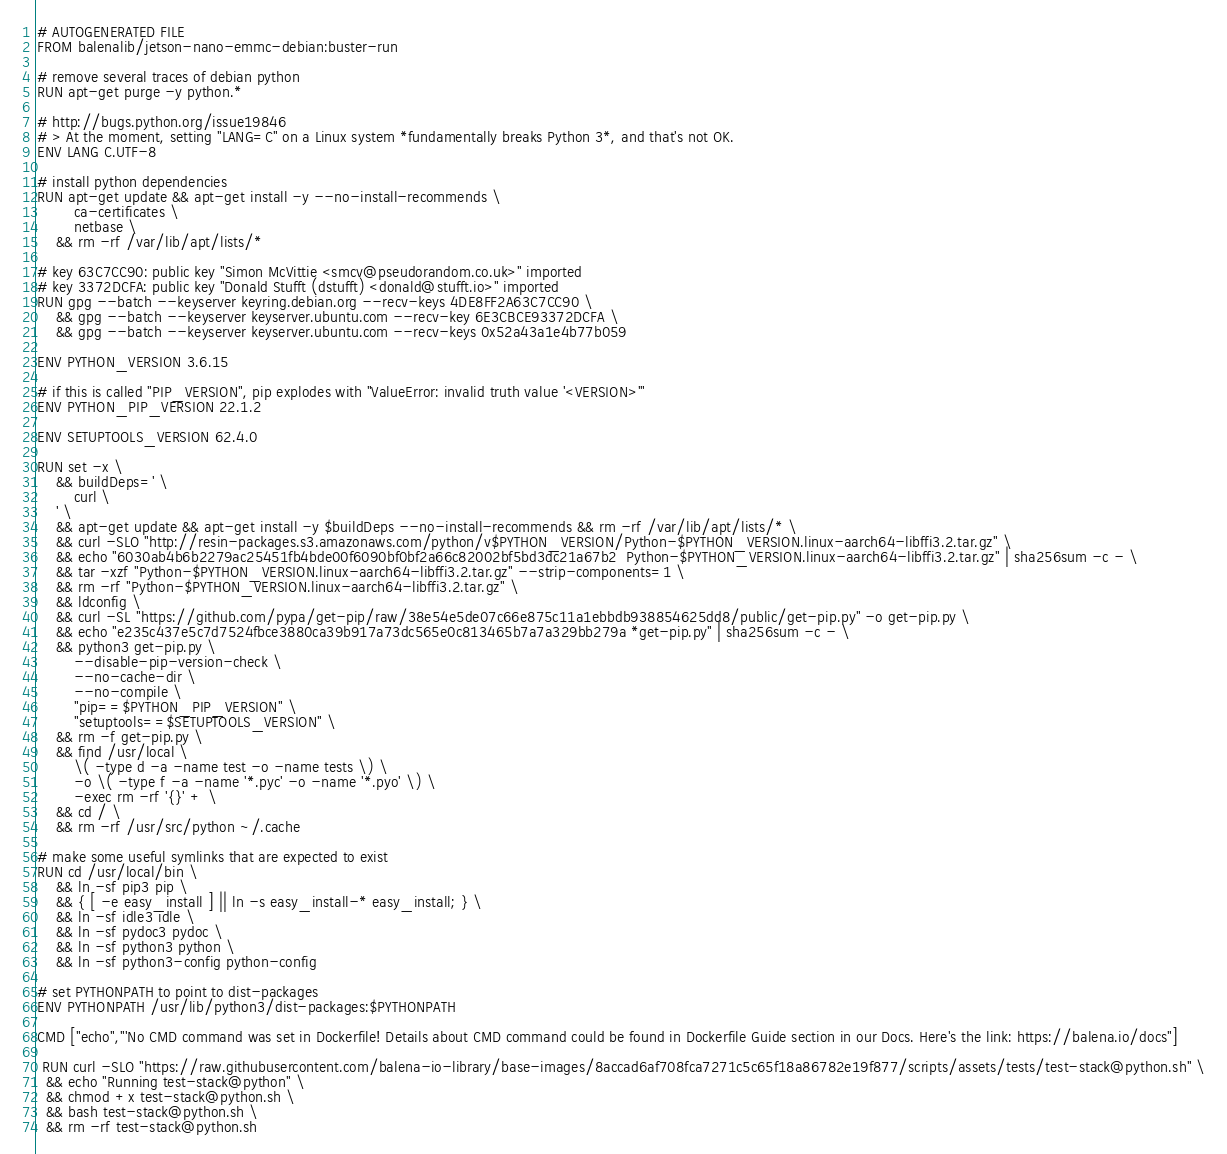<code> <loc_0><loc_0><loc_500><loc_500><_Dockerfile_># AUTOGENERATED FILE
FROM balenalib/jetson-nano-emmc-debian:buster-run

# remove several traces of debian python
RUN apt-get purge -y python.*

# http://bugs.python.org/issue19846
# > At the moment, setting "LANG=C" on a Linux system *fundamentally breaks Python 3*, and that's not OK.
ENV LANG C.UTF-8

# install python dependencies
RUN apt-get update && apt-get install -y --no-install-recommends \
		ca-certificates \
		netbase \
	&& rm -rf /var/lib/apt/lists/*

# key 63C7CC90: public key "Simon McVittie <smcv@pseudorandom.co.uk>" imported
# key 3372DCFA: public key "Donald Stufft (dstufft) <donald@stufft.io>" imported
RUN gpg --batch --keyserver keyring.debian.org --recv-keys 4DE8FF2A63C7CC90 \
	&& gpg --batch --keyserver keyserver.ubuntu.com --recv-key 6E3CBCE93372DCFA \
	&& gpg --batch --keyserver keyserver.ubuntu.com --recv-keys 0x52a43a1e4b77b059

ENV PYTHON_VERSION 3.6.15

# if this is called "PIP_VERSION", pip explodes with "ValueError: invalid truth value '<VERSION>'"
ENV PYTHON_PIP_VERSION 22.1.2

ENV SETUPTOOLS_VERSION 62.4.0

RUN set -x \
	&& buildDeps=' \
		curl \
	' \
	&& apt-get update && apt-get install -y $buildDeps --no-install-recommends && rm -rf /var/lib/apt/lists/* \
	&& curl -SLO "http://resin-packages.s3.amazonaws.com/python/v$PYTHON_VERSION/Python-$PYTHON_VERSION.linux-aarch64-libffi3.2.tar.gz" \
	&& echo "6030ab4b6b2279ac25451fb4bde00f6090bf0bf2a66c82002bf5bd3dc21a67b2  Python-$PYTHON_VERSION.linux-aarch64-libffi3.2.tar.gz" | sha256sum -c - \
	&& tar -xzf "Python-$PYTHON_VERSION.linux-aarch64-libffi3.2.tar.gz" --strip-components=1 \
	&& rm -rf "Python-$PYTHON_VERSION.linux-aarch64-libffi3.2.tar.gz" \
	&& ldconfig \
	&& curl -SL "https://github.com/pypa/get-pip/raw/38e54e5de07c66e875c11a1ebbdb938854625dd8/public/get-pip.py" -o get-pip.py \
    && echo "e235c437e5c7d7524fbce3880ca39b917a73dc565e0c813465b7a7a329bb279a *get-pip.py" | sha256sum -c - \
    && python3 get-pip.py \
        --disable-pip-version-check \
        --no-cache-dir \
        --no-compile \
        "pip==$PYTHON_PIP_VERSION" \
        "setuptools==$SETUPTOOLS_VERSION" \
	&& rm -f get-pip.py \
	&& find /usr/local \
		\( -type d -a -name test -o -name tests \) \
		-o \( -type f -a -name '*.pyc' -o -name '*.pyo' \) \
		-exec rm -rf '{}' + \
	&& cd / \
	&& rm -rf /usr/src/python ~/.cache

# make some useful symlinks that are expected to exist
RUN cd /usr/local/bin \
	&& ln -sf pip3 pip \
	&& { [ -e easy_install ] || ln -s easy_install-* easy_install; } \
	&& ln -sf idle3 idle \
	&& ln -sf pydoc3 pydoc \
	&& ln -sf python3 python \
	&& ln -sf python3-config python-config

# set PYTHONPATH to point to dist-packages
ENV PYTHONPATH /usr/lib/python3/dist-packages:$PYTHONPATH

CMD ["echo","'No CMD command was set in Dockerfile! Details about CMD command could be found in Dockerfile Guide section in our Docs. Here's the link: https://balena.io/docs"]

 RUN curl -SLO "https://raw.githubusercontent.com/balena-io-library/base-images/8accad6af708fca7271c5c65f18a86782e19f877/scripts/assets/tests/test-stack@python.sh" \
  && echo "Running test-stack@python" \
  && chmod +x test-stack@python.sh \
  && bash test-stack@python.sh \
  && rm -rf test-stack@python.sh 
</code> 